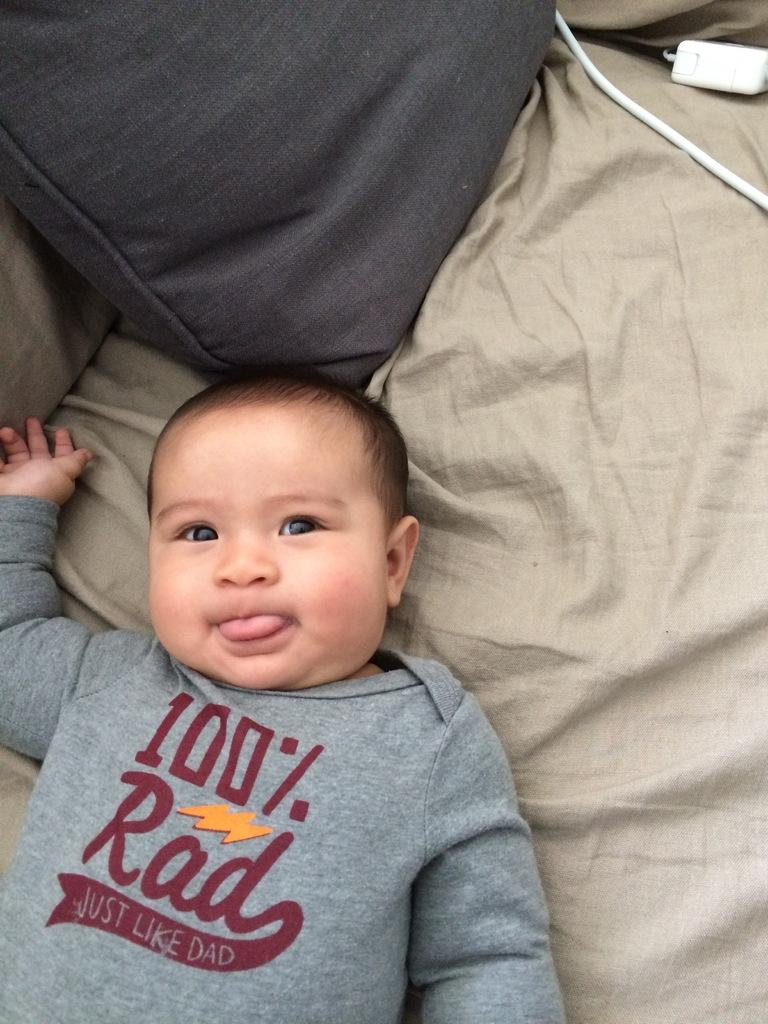What is the main subject of the picture? The main subject of the picture is a baby. Where is the baby located in the image? The baby is on a bed. What else can be seen on the bed in the image? There is a pillow on the bed. What type of leg is visible in the image? There is no leg visible in the image; it features a baby on a bed with a pillow. Is there a maid in the image? There is no mention of a maid in the image, as it only shows a baby on a bed with a pillow. 